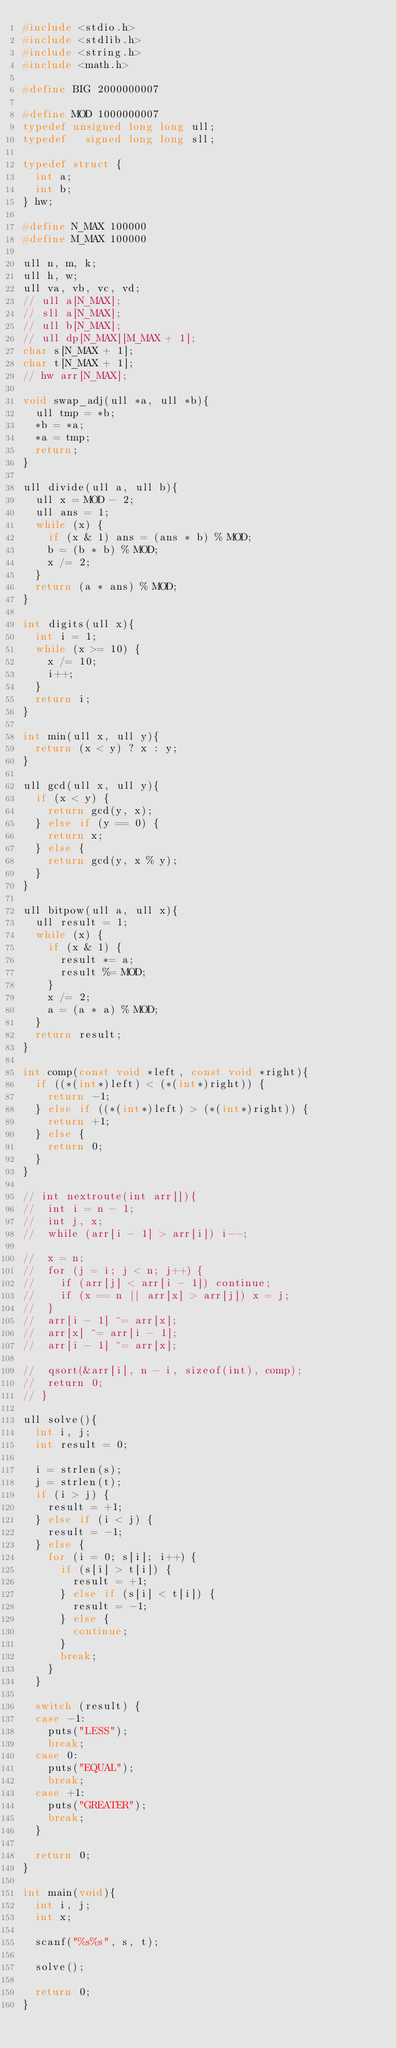<code> <loc_0><loc_0><loc_500><loc_500><_C_>#include <stdio.h>
#include <stdlib.h>
#include <string.h>
#include <math.h>
 
#define BIG 2000000007
 
#define MOD 1000000007
typedef unsigned long long ull;
typedef   signed long long sll;
 
typedef struct {
	int a;
	int b;
} hw;
 
#define N_MAX 100000
#define M_MAX 100000
 
ull n, m, k;
ull h, w;
ull va, vb, vc, vd;
// ull a[N_MAX];
// sll a[N_MAX];
// ull b[N_MAX];
// ull dp[N_MAX][M_MAX + 1];
char s[N_MAX + 1];
char t[N_MAX + 1];
// hw arr[N_MAX];
 
void swap_adj(ull *a, ull *b){
	ull tmp = *b;
	*b = *a;
	*a = tmp;
	return;
}

ull divide(ull a, ull b){
	ull x = MOD - 2;
	ull ans = 1;
	while (x) {
		if (x & 1) ans = (ans * b) % MOD;
		b = (b * b) % MOD;
		x /= 2;
	}
	return (a * ans) % MOD;
}
 
int digits(ull x){
	int i = 1;
	while (x >= 10) {
		x /= 10;
		i++;
	}
	return i;
}
 
int min(ull x, ull y){
	return (x < y) ? x : y;
}
 
ull gcd(ull x, ull y){
	if (x < y) {
		return gcd(y, x);
	} else if (y == 0) {
		return x;
	} else {
		return gcd(y, x % y);
	}
}
 
ull bitpow(ull a, ull x){
	ull result = 1;
	while (x) {
		if (x & 1) {
			result *= a;
			result %= MOD;
		}
		x /= 2;
		a = (a * a) % MOD;
	}
	return result;
}

int comp(const void *left, const void *right){
	if ((*(int*)left) < (*(int*)right)) {
		return -1;
	} else if ((*(int*)left) > (*(int*)right)) {
		return +1;
	} else {
		return 0;
	}
}

// int nextroute(int arr[]){
// 	int i = n - 1;
// 	int j, x;
// 	while (arr[i - 1] > arr[i]) i--;

// 	x = n;
// 	for (j = i; j < n; j++) {
// 		if (arr[j] < arr[i - 1]) continue;
// 		if (x == n || arr[x] > arr[j]) x = j;
// 	}
// 	arr[i - 1] ^= arr[x];
// 	arr[x] ^= arr[i - 1];
// 	arr[i - 1] ^= arr[x];

// 	qsort(&arr[i], n - i, sizeof(int), comp);
// 	return 0;
// }

ull solve(){
	int i, j;
	int result = 0;

	i = strlen(s);
	j = strlen(t);
	if (i > j) {
		result = +1;
	} else if (i < j) {
		result = -1;
	} else {
		for (i = 0; s[i]; i++) {
			if (s[i] > t[i]) {
				result = +1;
			} else if (s[i] < t[i]) {
				result = -1;
			} else {
				continue;
			}
			break;
		}
	}

	switch (result) {
	case -1:
		puts("LESS");
		break;
	case 0:
		puts("EQUAL");
		break;
	case +1:
		puts("GREATER");
		break;
	}

	return 0;
}
 
int main(void){
	int i, j;
	int x;

	scanf("%s%s", s, t);

	solve();

	return 0;
}
</code> 